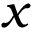Convert formula to latex. <formula><loc_0><loc_0><loc_500><loc_500>x</formula> 